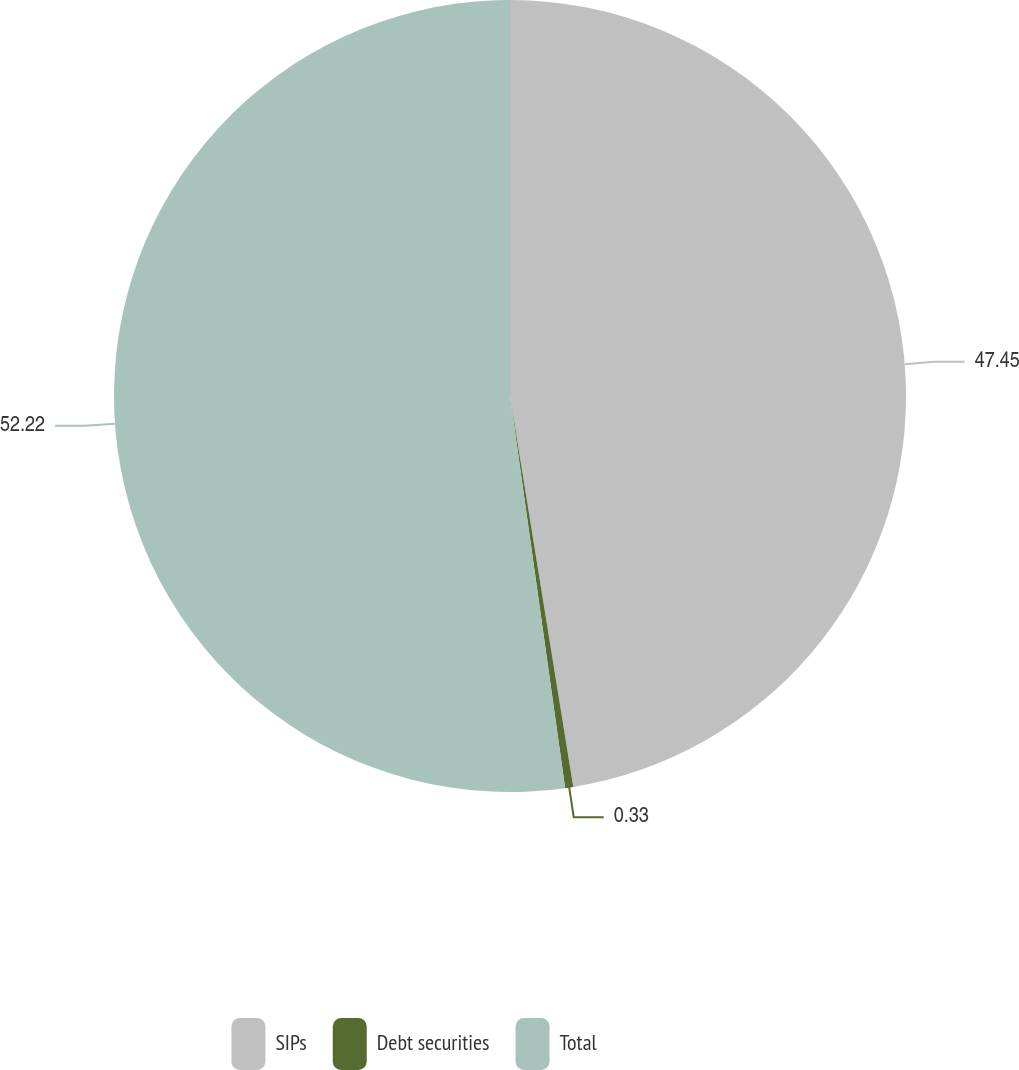<chart> <loc_0><loc_0><loc_500><loc_500><pie_chart><fcel>SIPs<fcel>Debt securities<fcel>Total<nl><fcel>47.45%<fcel>0.33%<fcel>52.23%<nl></chart> 